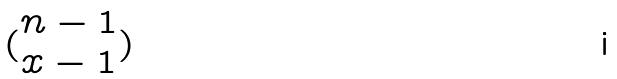<formula> <loc_0><loc_0><loc_500><loc_500>( \begin{matrix} n - 1 \\ x - 1 \end{matrix} )</formula> 